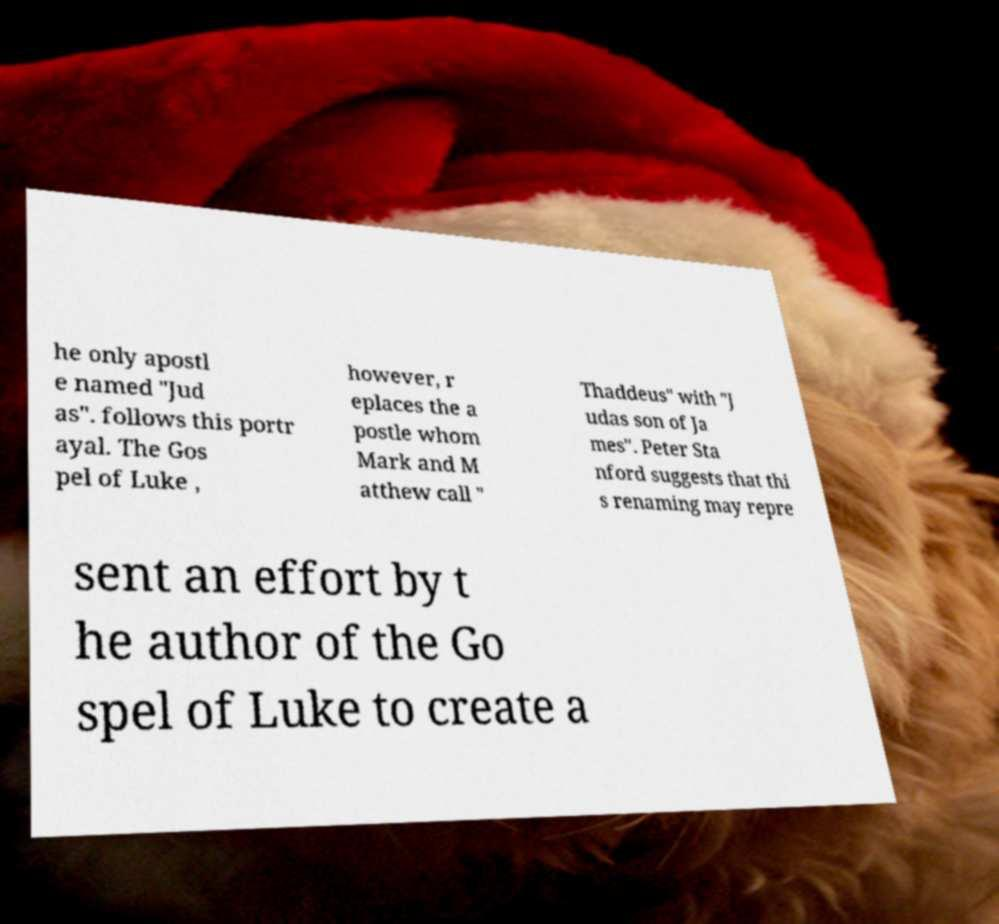Could you extract and type out the text from this image? he only apostl e named "Jud as". follows this portr ayal. The Gos pel of Luke , however, r eplaces the a postle whom Mark and M atthew call " Thaddeus" with "J udas son of Ja mes". Peter Sta nford suggests that thi s renaming may repre sent an effort by t he author of the Go spel of Luke to create a 